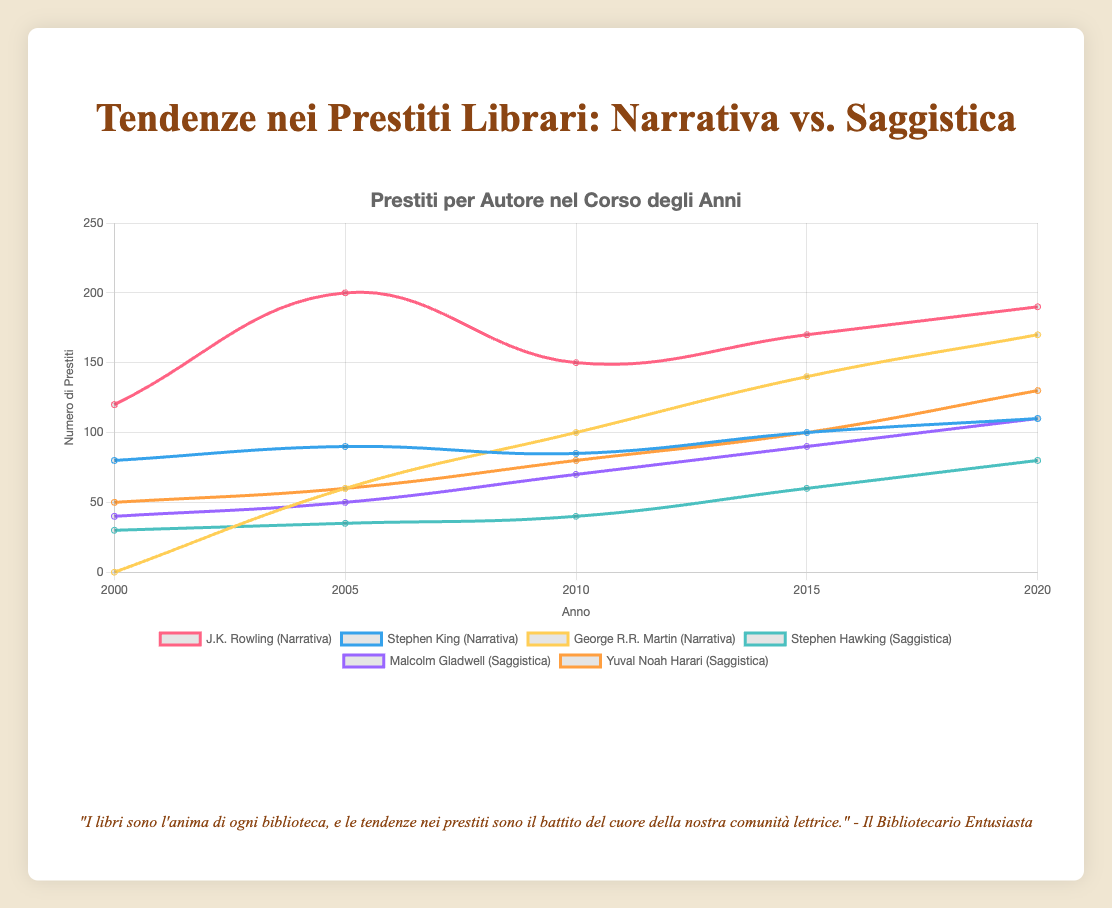Which author had the highest number of book borrowings in 2020? Looking at the chart for the year 2020, the orange line representing 'Other Authors' in non-fiction has the highest point at 250.
Answer: Other Authors (Fiction) Did Stephen King or George R.R. Martin have more borrowings in 2010? Looking at the chart for the year 2010, Stephen King had 85 borrowings (blue line) while George R.R. Martin had 100 (yellow line).
Answer: George R.R. Martin How did the number of borrowings for J.K. Rowling change from 2000 to 2020? In the chart, J.K. Rowling's borrowings start at 120 in 2000 (pink line) and rise to 190 by 2020.
Answer: Increased by 70 What was the total number of borrowings for Yuval Noah Harari between 2000 and 2020? Sum the data points for Yuval Noah Harari (orange line) across the years: 50 (2000) + 60 (2005) + 80 (2010) + 100 (2015) + 130 (2020). The total is 420.
Answer: 420 Which author had the lowest number of borrowings in 2005? The chart shows Stephen Hawking (cyan line) had the lowest number of borrowings in 2005 with 35.
Answer: Stephen Hawking Which fiction author saw the most significant increase in borrowings between 2015 and 2020? Calculating the increase from 2015 to 2020 for fiction authors: J.K. Rowling (170 to 190 = 20), Stephen King (100 to 110 = 10), George R.R. Martin (140 to 170 = 30).
Answer: George R.R. Martin What is the average number of borrowings for Malcolm Gladwell from 2000 to 2020? The data points for Malcolm Gladwell (purple line) are: 40 (2000), 50 (2005), 70 (2010), 90 (2015), 110 (2020). Sum them up to get 360 and divide by 5 (number of data points). The average is 360 / 5.
Answer: 72 Which year had the highest total number of book borrowings for both fiction and non-fiction? Sum the borrowings for all authors in each year and compare: 2000 (120+80+70+150+30+40+50+100=640), 2005 (200+90+60+180+35+50+60+120=795), 2010 (150+85+100+160+40+70+80+140=825), 2015 (170+100+140+200+60+90+100+180=1040), 2020 (190+110+170+250+80+110+130+200=1240). The year 2020 was the highest with 1240.
Answer: 2020 